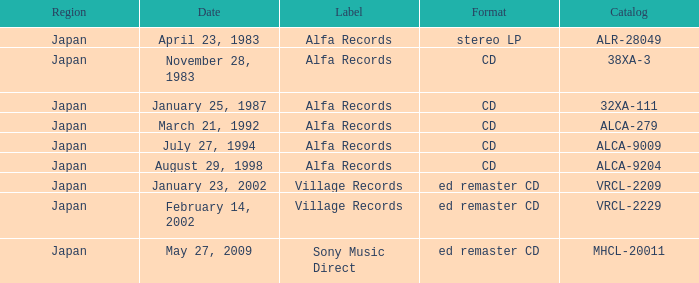What is the structure of the date february 14, 2002? Ed remaster cd. 